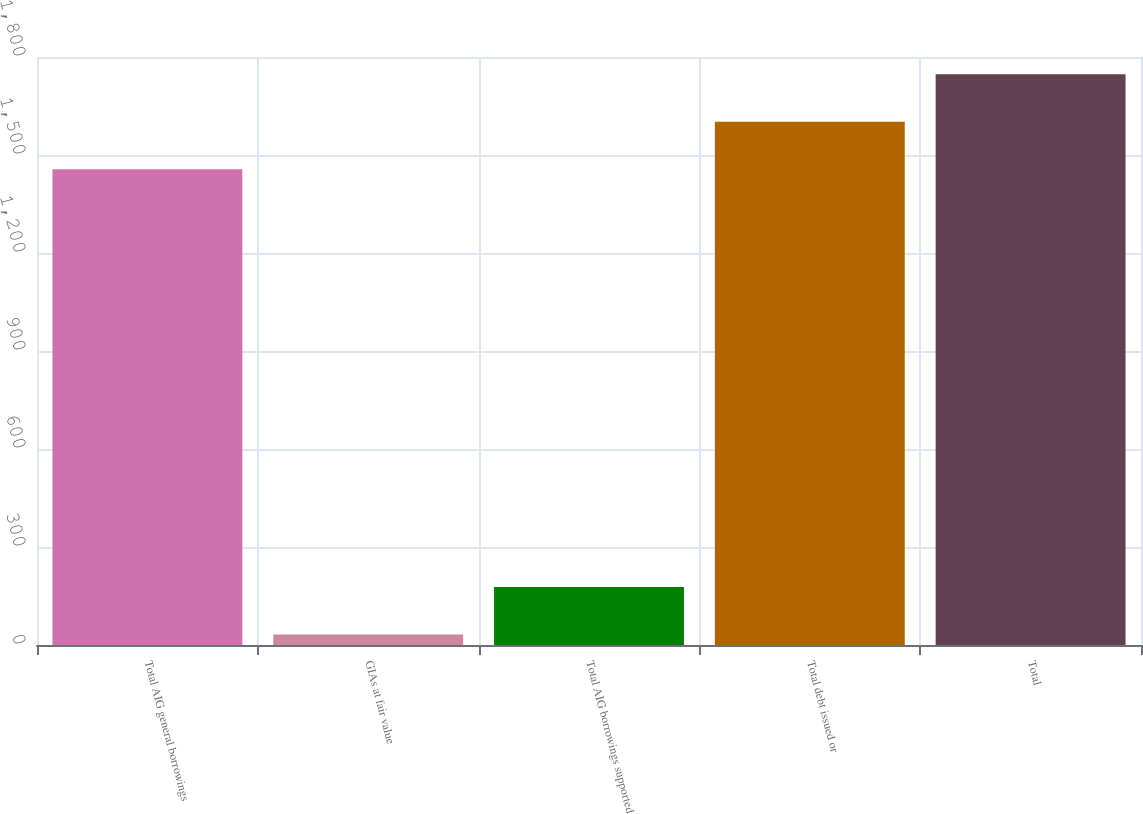Convert chart to OTSL. <chart><loc_0><loc_0><loc_500><loc_500><bar_chart><fcel>Total AIG general borrowings<fcel>GIAs at fair value<fcel>Total AIG borrowings supported<fcel>Total debt issued or<fcel>Total<nl><fcel>1456<fcel>32<fcel>177.6<fcel>1601.6<fcel>1747.2<nl></chart> 